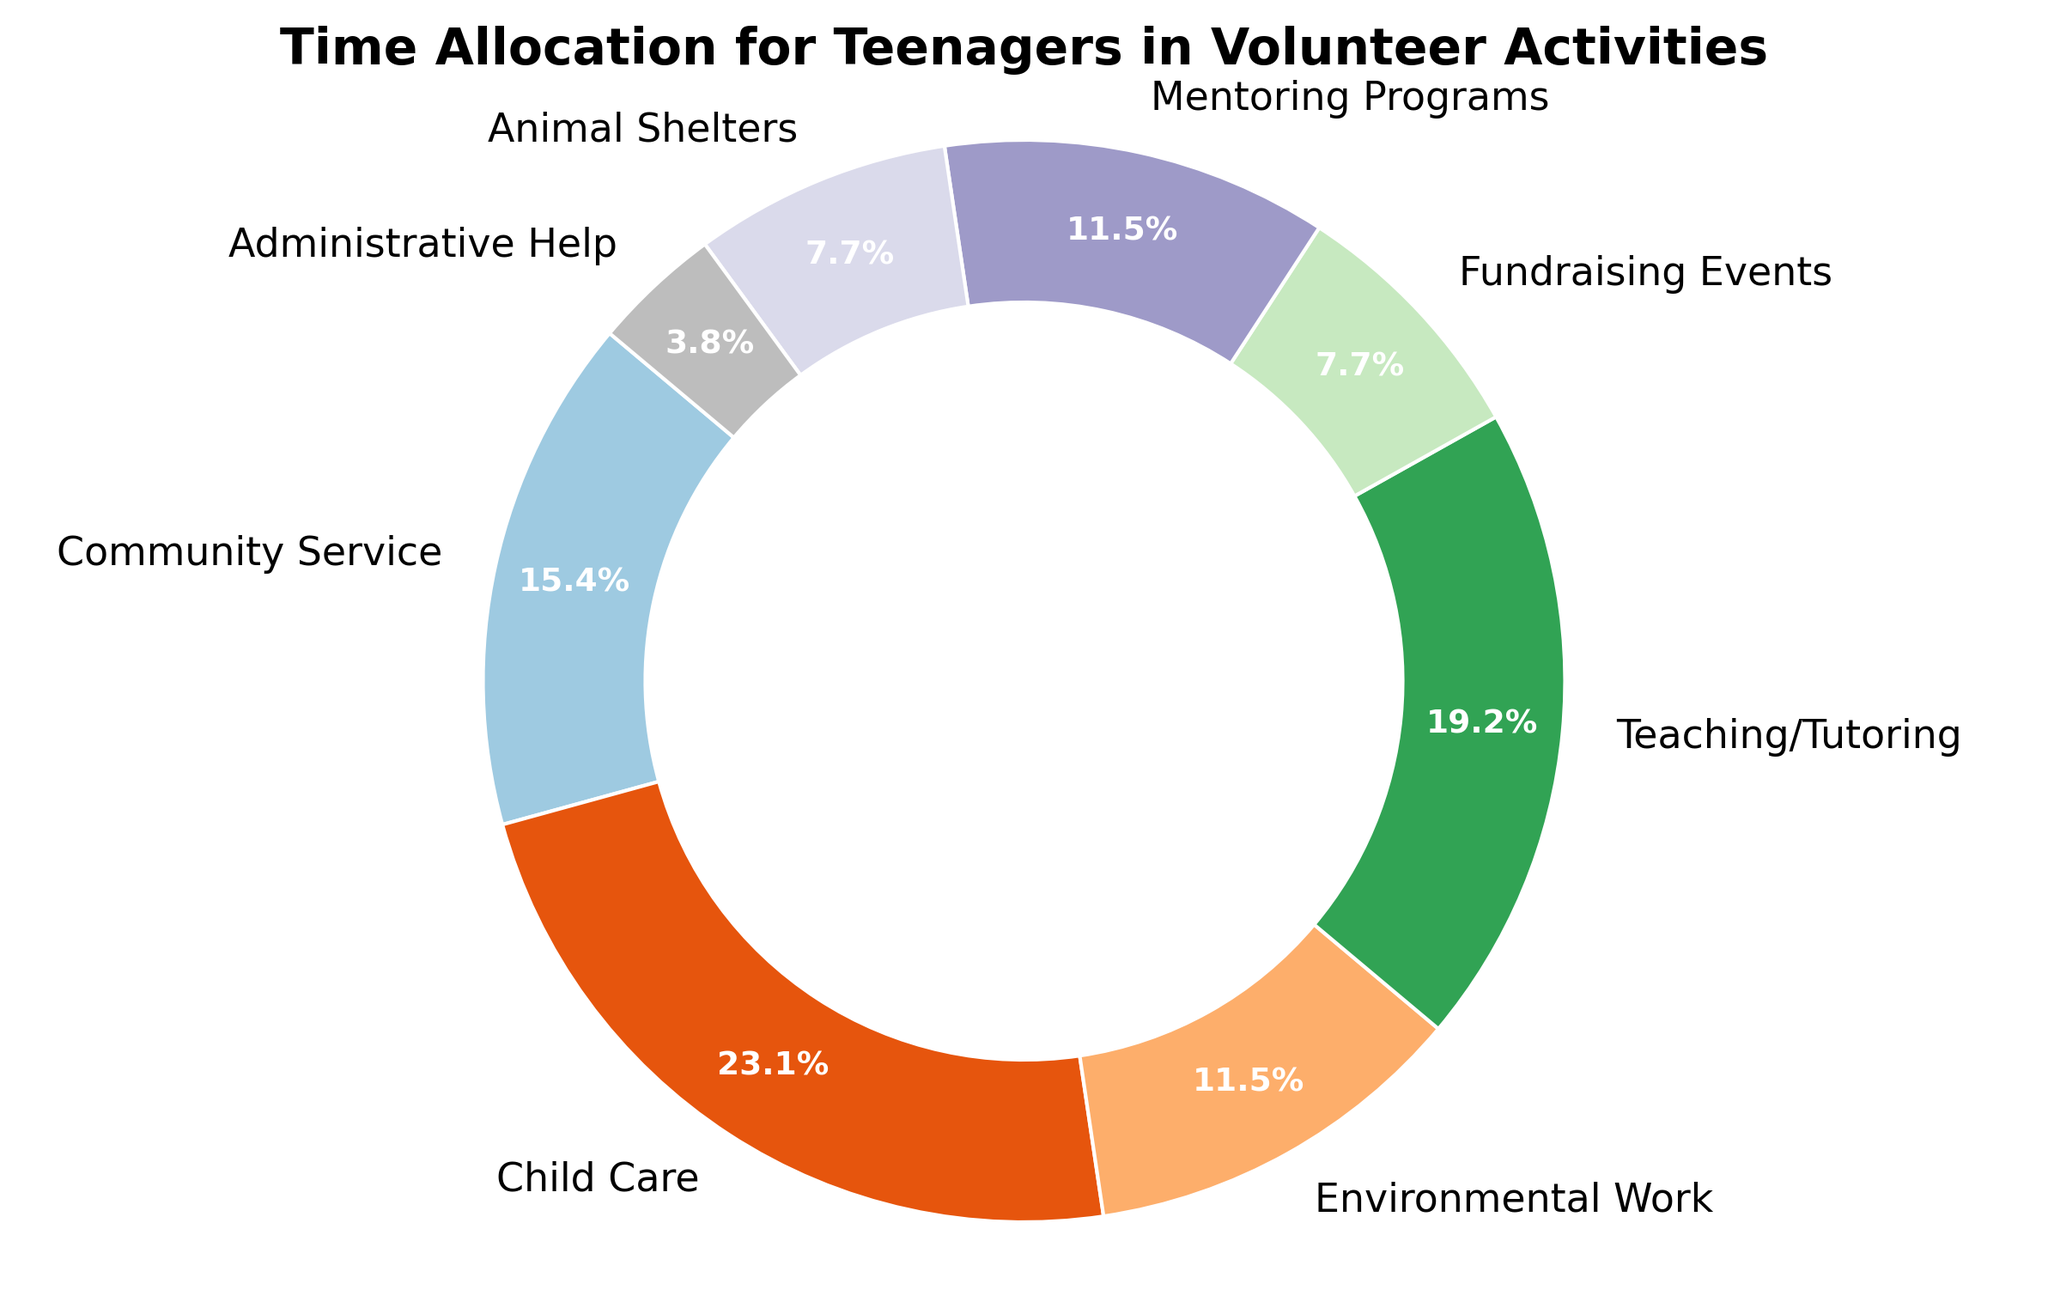What percentage of their volunteer time do teenagers spend on Child Care? To find the percentage of time spent on Child Care, look at the pie chart's section labeled 'Child Care'. The label shows the percentage.
Answer: 28.6% Which activity takes up more of teenagers' time, Community Service or Teaching/Tutoring? To compare, look at the sections labeled 'Community Service' and 'Teaching/Tutoring'. Identify the larger percentage: Community Service: 19%, Teaching/Tutoring: 23.8%. Therefore, Teaching/Tutoring takes up more time.
Answer: Teaching/Tutoring What is the total percentage of time teens allocate to Environmental Work and Mentoring Programs? Add the percentage values of 'Environmental Work' and 'Mentoring Programs' from the chart. Environmental Work: 14.3%, Mentoring Programs: 14.3%. Total percentage is 14.3% + 14.3% = 28.6%.
Answer: 28.6% Which activity do teenagers spend the least amount of time on, and what is the percentage? Look at the smallest section of the pie chart. The label will indicate the activity and its percentage. The smallest section is 'Administrative Help' with 4.8%.
Answer: Administrative Help, 4.8% Do teenagers spend more time on Animal Shelters or Fundraising Events? Compare the pie chart sections for 'Animal Shelters' and 'Fundraising Events'. Animal Shelters: 9.5%, Fundraising Events: 9.5%. Both have the same percentage.
Answer: Both are equal How much more time (in percentage) do teenagers spend on Child Care than on Environmental Work? Subtract the percentage of time spent on 'Environmental Work' from that spent on 'Child Care' in the chart. Child Care: 28.6%, Environmental Work: 14.3%. Difference is 28.6% - 14.3% = 14.3%.
Answer: 14.3% If the total volunteer hours per week are 26, how many hours do teenagers spend on Fundraising Events? Calculate the percentage of time spent on Fundraising Events and apply it to the total hours. Fundraising Events: 9.5%. Total time = 9.5% of 26 hours. Hours spent = 0.095 * 26 = 2.47 hours, approximated to 2.5 hours.
Answer: 2.5 hours Which visual attribute (color) is used for Mentoring Programs? Identify the color of the section labeled 'Mentoring Programs' in the pie chart. Choose the color most obviously associated with the section.
Answer: [Appropriate color based on chart] 